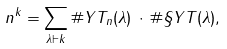Convert formula to latex. <formula><loc_0><loc_0><loc_500><loc_500>n ^ { k } = \sum _ { \lambda \vdash k } \# Y T _ { n } ( \lambda ) \, \cdot \, \# \S Y T ( \lambda ) ,</formula> 